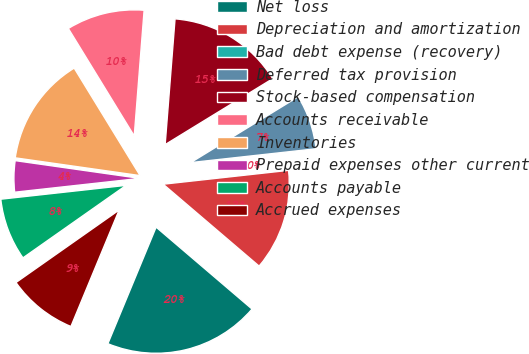Convert chart. <chart><loc_0><loc_0><loc_500><loc_500><pie_chart><fcel>Net loss<fcel>Depreciation and amortization<fcel>Bad debt expense (recovery)<fcel>Deferred tax provision<fcel>Stock-based compensation<fcel>Accounts receivable<fcel>Inventories<fcel>Prepaid expenses other current<fcel>Accounts payable<fcel>Accrued expenses<nl><fcel>20.0%<fcel>13.0%<fcel>0.0%<fcel>7.0%<fcel>15.0%<fcel>10.0%<fcel>14.0%<fcel>4.0%<fcel>8.0%<fcel>9.0%<nl></chart> 